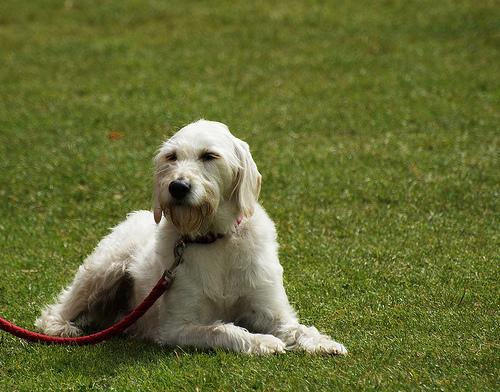In a referential expression grounding task, provide a brief description of the dog's eyes. The dog has a pair of dark, black eyes that appear very striking against its white fur. Mention the position of the dog and the condition of its ears. The dog is lying down with its head turned to the side, and it has long, floppy ears that lay down its face. Provide a selling point for a product or service related to dogs using the image as inspiration. Keep your beloved long-haired dog looking clean and stylish with our premium grooming services and a trendy red collar and leash set. Where is the dog situated and what is the distinctive color of its collar and leash? The dog is laying down on green grass, and it has a red collar with a matching red leash attached to it. What color is the dog's nose and eyes, and what is the state of its mouth hair? The dog has a black nose and black eyes, and its mouth hair is dirty or stained. For a multi-choice VQA task, list four color possibilities for the dog's leash and identify which one is correct. d) Yellow In the context of visual entailment, describe the relationship between the dog and the grass. The dog is lying down on the green grass, suggesting that it is probably enjoying a relaxed time in a natural environment. What are some visible features of the dog that could be used in a product advertisement? The dog's white fur, black eyes, and red collar and leash could be highlighted in a product advertisement for pet accessories, grooming services, or outdoor pet products. Describe the physical appearance of the dog and its surrounding environment. The dog is mostly white with long fur, floppy ears, black eyes, and a black nose. It's lying down on green grass with a red collar and leash attached. There's a brown leaf on the grass near the dog. Identify the dog's body posture and mention one distinctive feature related to its face. The dog is laying down with its head turned to the side, and it has a black nose on the tip of its snout. 